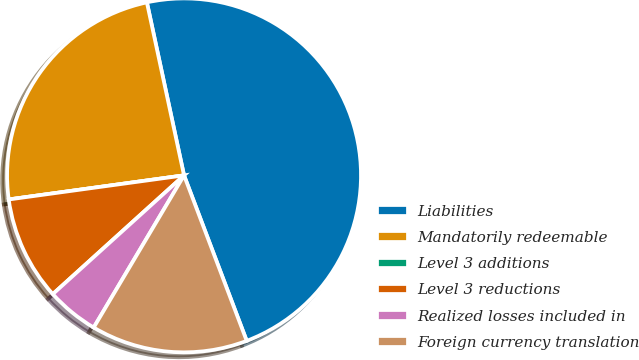Convert chart to OTSL. <chart><loc_0><loc_0><loc_500><loc_500><pie_chart><fcel>Liabilities<fcel>Mandatorily redeemable<fcel>Level 3 additions<fcel>Level 3 reductions<fcel>Realized losses included in<fcel>Foreign currency translation<nl><fcel>47.61%<fcel>23.81%<fcel>0.0%<fcel>9.53%<fcel>4.77%<fcel>14.29%<nl></chart> 